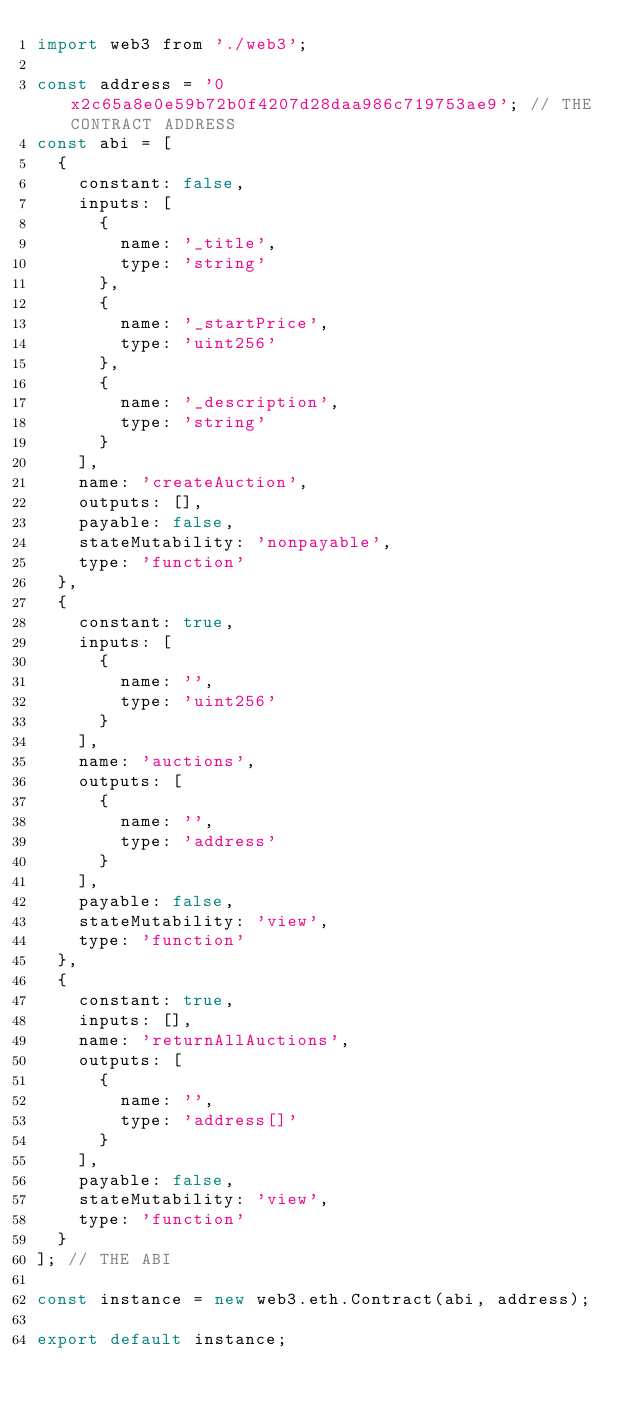<code> <loc_0><loc_0><loc_500><loc_500><_JavaScript_>import web3 from './web3';

const address = '0x2c65a8e0e59b72b0f4207d28daa986c719753ae9'; // THE CONTRACT ADDRESS
const abi = [
  {
    constant: false,
    inputs: [
      {
        name: '_title',
        type: 'string'
      },
      {
        name: '_startPrice',
        type: 'uint256'
      },
      {
        name: '_description',
        type: 'string'
      }
    ],
    name: 'createAuction',
    outputs: [],
    payable: false,
    stateMutability: 'nonpayable',
    type: 'function'
  },
  {
    constant: true,
    inputs: [
      {
        name: '',
        type: 'uint256'
      }
    ],
    name: 'auctions',
    outputs: [
      {
        name: '',
        type: 'address'
      }
    ],
    payable: false,
    stateMutability: 'view',
    type: 'function'
  },
  {
    constant: true,
    inputs: [],
    name: 'returnAllAuctions',
    outputs: [
      {
        name: '',
        type: 'address[]'
      }
    ],
    payable: false,
    stateMutability: 'view',
    type: 'function'
  }
]; // THE ABI

const instance = new web3.eth.Contract(abi, address);

export default instance;
</code> 